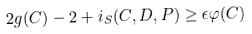Convert formula to latex. <formula><loc_0><loc_0><loc_500><loc_500>2 g ( C ) - 2 + i _ { S } ( C , D , P ) \geq \epsilon \varphi ( C )</formula> 